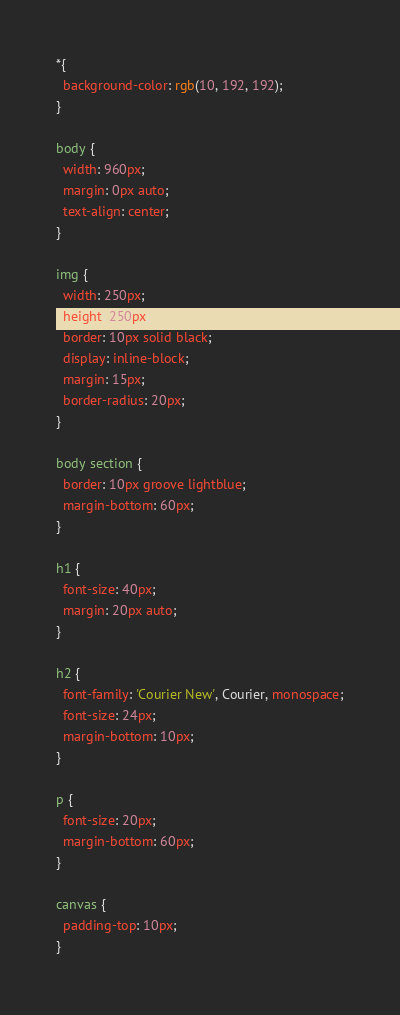Convert code to text. <code><loc_0><loc_0><loc_500><loc_500><_CSS_>*{
  background-color: rgb(10, 192, 192);
}

body {
  width: 960px;
  margin: 0px auto;
  text-align: center;
}

img {
  width: 250px;
  height: 250px;
  border: 10px solid black;
  display: inline-block;
  margin: 15px;
  border-radius: 20px;
}

body section {
  border: 10px groove lightblue;
  margin-bottom: 60px;
}

h1 {
  font-size: 40px;
  margin: 20px auto;
}

h2 {
  font-family: 'Courier New', Courier, monospace;
  font-size: 24px;
  margin-bottom: 10px;
}

p {
  font-size: 20px;
  margin-bottom: 60px;
}

canvas {
  padding-top: 10px;
}</code> 